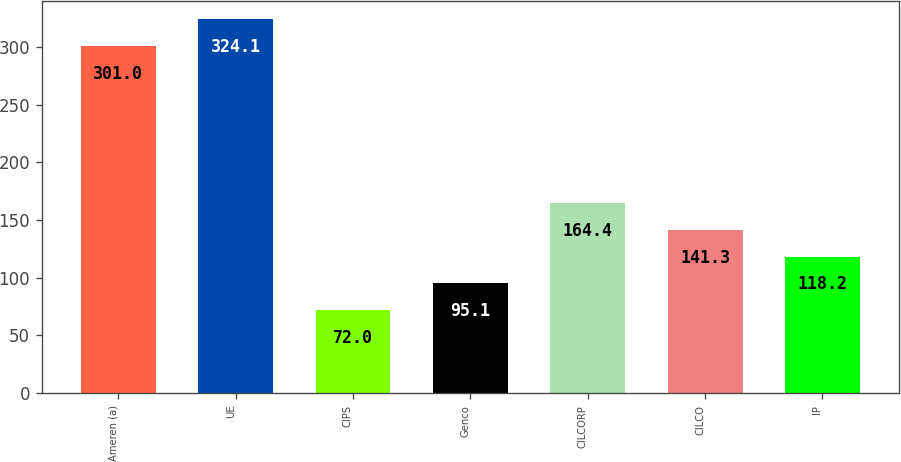<chart> <loc_0><loc_0><loc_500><loc_500><bar_chart><fcel>Ameren (a)<fcel>UE<fcel>CIPS<fcel>Genco<fcel>CILCORP<fcel>CILCO<fcel>IP<nl><fcel>301<fcel>324.1<fcel>72<fcel>95.1<fcel>164.4<fcel>141.3<fcel>118.2<nl></chart> 